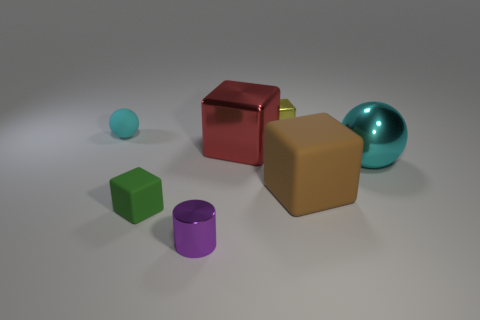Does the yellow shiny object have the same shape as the big brown rubber thing?
Offer a very short reply. Yes. Is there anything else that is the same color as the small metal cylinder?
Offer a very short reply. No. Do the big rubber object and the small shiny object behind the large brown matte block have the same shape?
Provide a short and direct response. Yes. The tiny block in front of the cyan ball that is to the right of the tiny metallic thing behind the small matte block is what color?
Your answer should be compact. Green. Are there any other things that are the same material as the small green thing?
Provide a succinct answer. Yes. There is a large metallic thing behind the metallic ball; does it have the same shape as the green matte thing?
Provide a succinct answer. Yes. What is the material of the purple object?
Keep it short and to the point. Metal. The tiny object behind the small rubber thing that is behind the matte cube right of the small cylinder is what shape?
Ensure brevity in your answer.  Cube. What number of other things are the same shape as the large red metal thing?
Provide a short and direct response. 3. Is the color of the tiny matte ball the same as the sphere that is to the right of the small yellow shiny block?
Keep it short and to the point. Yes. 